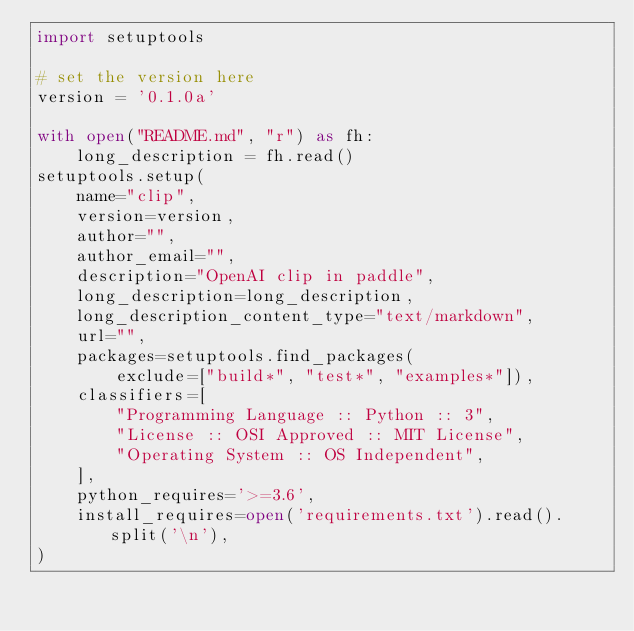<code> <loc_0><loc_0><loc_500><loc_500><_Python_>import setuptools

# set the version here
version = '0.1.0a'

with open("README.md", "r") as fh:
    long_description = fh.read()
setuptools.setup(
    name="clip",
    version=version,
    author="",
    author_email="",
    description="OpenAI clip in paddle",
    long_description=long_description,
    long_description_content_type="text/markdown",
    url="",
    packages=setuptools.find_packages(
        exclude=["build*", "test*", "examples*"]),
    classifiers=[
        "Programming Language :: Python :: 3",
        "License :: OSI Approved :: MIT License",
        "Operating System :: OS Independent",
    ],
    python_requires='>=3.6',
    install_requires=open('requirements.txt').read().split('\n'),
)
</code> 